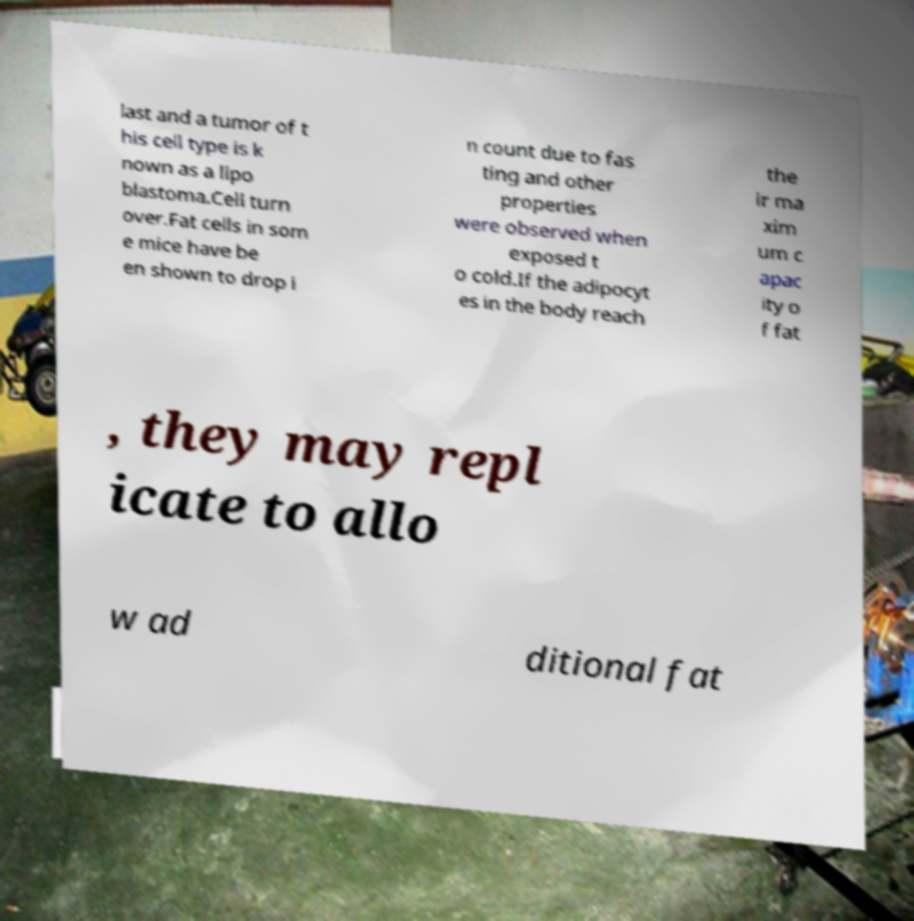I need the written content from this picture converted into text. Can you do that? last and a tumor of t his cell type is k nown as a lipo blastoma.Cell turn over.Fat cells in som e mice have be en shown to drop i n count due to fas ting and other properties were observed when exposed t o cold.If the adipocyt es in the body reach the ir ma xim um c apac ity o f fat , they may repl icate to allo w ad ditional fat 